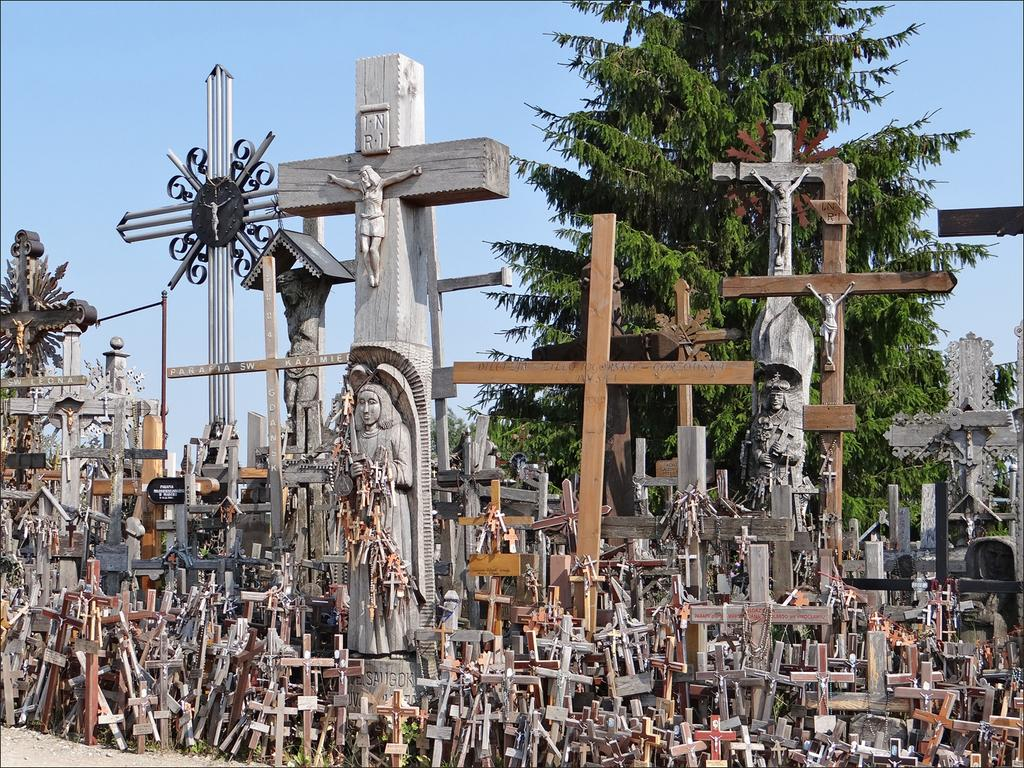What religious symbols can be seen in the image? There are crosses in the image. What type of artwork is present in the image? There are sculptures in the image. What natural element is visible in the background of the image? There is a tree in the background of the image. What is visible above the tree in the image? The sky is visible in the background of the image. Where is the park located in the image? There is no park present in the image. What is the starting point of the sculptures in the image? The sculptures do not have a starting point in the image; they are stationary objects. 